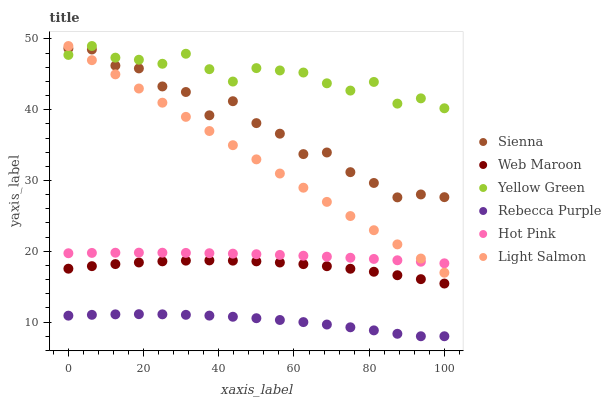Does Rebecca Purple have the minimum area under the curve?
Answer yes or no. Yes. Does Yellow Green have the maximum area under the curve?
Answer yes or no. Yes. Does Hot Pink have the minimum area under the curve?
Answer yes or no. No. Does Hot Pink have the maximum area under the curve?
Answer yes or no. No. Is Light Salmon the smoothest?
Answer yes or no. Yes. Is Sienna the roughest?
Answer yes or no. Yes. Is Yellow Green the smoothest?
Answer yes or no. No. Is Yellow Green the roughest?
Answer yes or no. No. Does Rebecca Purple have the lowest value?
Answer yes or no. Yes. Does Hot Pink have the lowest value?
Answer yes or no. No. Does Yellow Green have the highest value?
Answer yes or no. Yes. Does Hot Pink have the highest value?
Answer yes or no. No. Is Hot Pink less than Sienna?
Answer yes or no. Yes. Is Hot Pink greater than Web Maroon?
Answer yes or no. Yes. Does Light Salmon intersect Sienna?
Answer yes or no. Yes. Is Light Salmon less than Sienna?
Answer yes or no. No. Is Light Salmon greater than Sienna?
Answer yes or no. No. Does Hot Pink intersect Sienna?
Answer yes or no. No. 